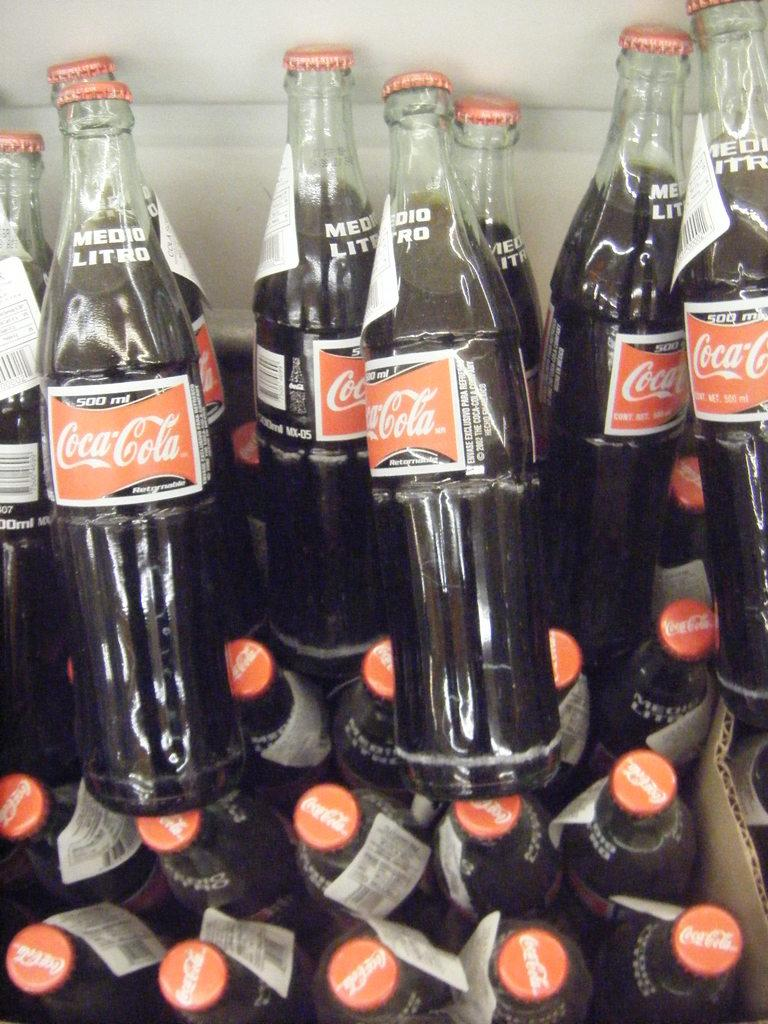<image>
Summarize the visual content of the image. Bottles of Coca-Cola are piled on top of each other. 